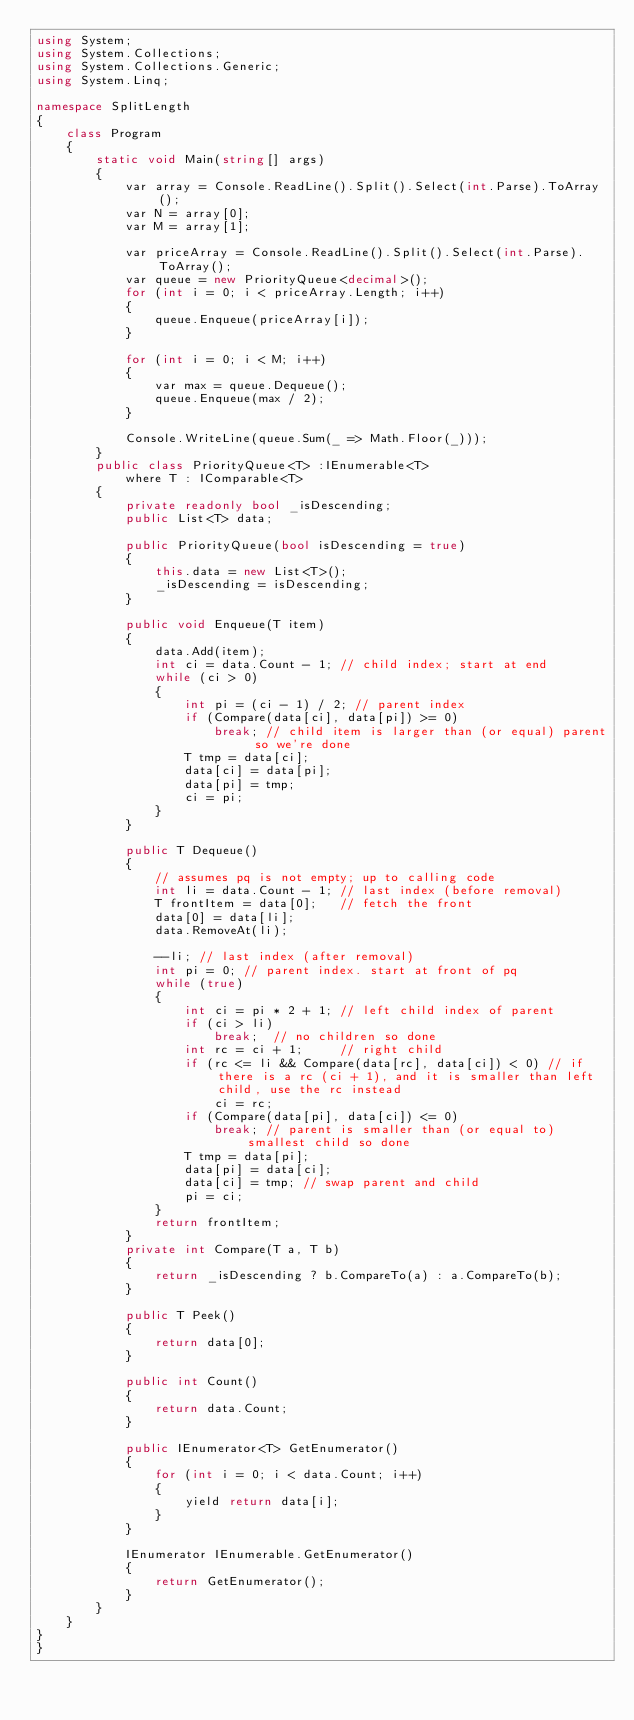Convert code to text. <code><loc_0><loc_0><loc_500><loc_500><_C#_>using System;
using System.Collections;
using System.Collections.Generic;
using System.Linq;

namespace SplitLength
{
    class Program
    {
        static void Main(string[] args)
        {
            var array = Console.ReadLine().Split().Select(int.Parse).ToArray();
            var N = array[0];
            var M = array[1];

            var priceArray = Console.ReadLine().Split().Select(int.Parse).ToArray();
            var queue = new PriorityQueue<decimal>();
            for (int i = 0; i < priceArray.Length; i++)
            {
                queue.Enqueue(priceArray[i]);
            }

            for (int i = 0; i < M; i++)
            {
                var max = queue.Dequeue();
                queue.Enqueue(max / 2);
            }

            Console.WriteLine(queue.Sum(_ => Math.Floor(_)));
        }
        public class PriorityQueue<T> :IEnumerable<T>
            where T : IComparable<T>
        {
            private readonly bool _isDescending;
            public List<T> data;

            public PriorityQueue(bool isDescending = true)
            {
                this.data = new List<T>();
                _isDescending = isDescending;
            }

            public void Enqueue(T item)
            {
                data.Add(item);
                int ci = data.Count - 1; // child index; start at end
                while (ci > 0)
                {
                    int pi = (ci - 1) / 2; // parent index
                    if (Compare(data[ci], data[pi]) >= 0)
                        break; // child item is larger than (or equal) parent so we're done
                    T tmp = data[ci];
                    data[ci] = data[pi];
                    data[pi] = tmp;
                    ci = pi;
                }
            }

            public T Dequeue()
            {
                // assumes pq is not empty; up to calling code
                int li = data.Count - 1; // last index (before removal)
                T frontItem = data[0];   // fetch the front
                data[0] = data[li];
                data.RemoveAt(li);

                --li; // last index (after removal)
                int pi = 0; // parent index. start at front of pq
                while (true)
                {
                    int ci = pi * 2 + 1; // left child index of parent
                    if (ci > li)
                        break;  // no children so done
                    int rc = ci + 1;     // right child
                    if (rc <= li && Compare(data[rc], data[ci]) < 0) // if there is a rc (ci + 1), and it is smaller than left child, use the rc instead
                        ci = rc;
                    if (Compare(data[pi], data[ci]) <= 0)
                        break; // parent is smaller than (or equal to) smallest child so done
                    T tmp = data[pi];
                    data[pi] = data[ci];
                    data[ci] = tmp; // swap parent and child
                    pi = ci;
                }
                return frontItem;
            }
            private int Compare(T a, T b)
            {
                return _isDescending ? b.CompareTo(a) : a.CompareTo(b);
            }

            public T Peek()
            {
                return data[0];
            }

            public int Count()
            {
                return data.Count;
            }

            public IEnumerator<T> GetEnumerator()
            {
                for (int i = 0; i < data.Count; i++)
                {
                    yield return data[i];
                }
            }

            IEnumerator IEnumerable.GetEnumerator()
            {
                return GetEnumerator();
            }
        }
    }
}
}
</code> 